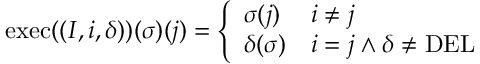Convert formula to latex. <formula><loc_0><loc_0><loc_500><loc_500>\begin{array} { r } { e x e c ( ( I , i , \delta ) ) ( \sigma ) ( j ) = \left \{ \begin{array} { l l } { \sigma ( j ) } & { i \neq j } \\ { \delta ( \sigma ) } & { i = j \wedge \delta \neq D E L } \end{array} } \end{array}</formula> 